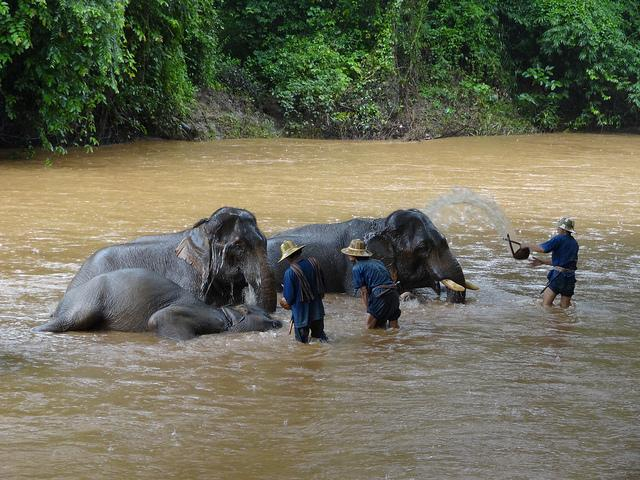What are the people doing to the elephants? Please explain your reasoning. cooling. The people cool them off. 